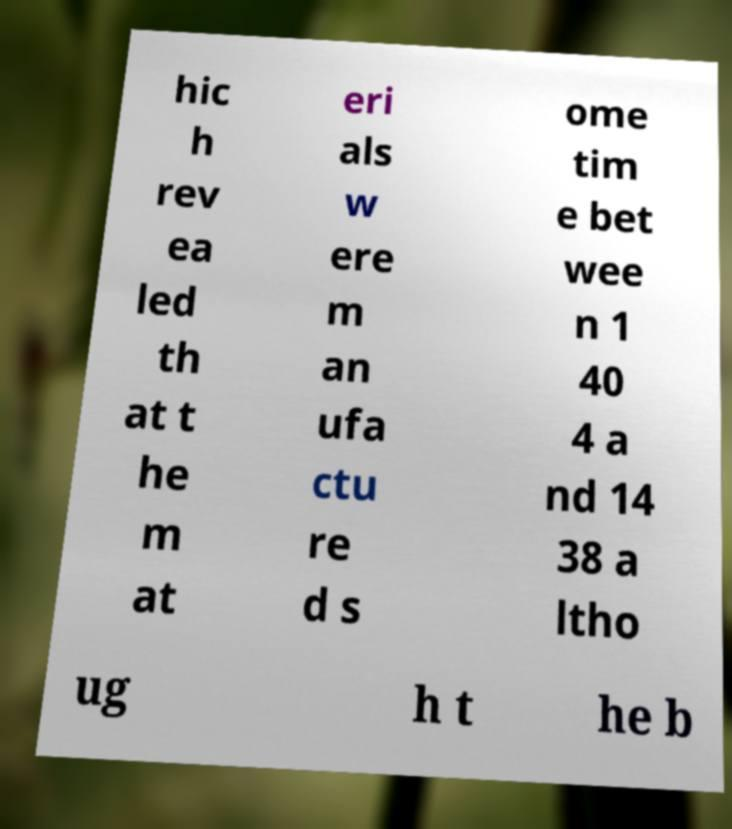Could you assist in decoding the text presented in this image and type it out clearly? hic h rev ea led th at t he m at eri als w ere m an ufa ctu re d s ome tim e bet wee n 1 40 4 a nd 14 38 a ltho ug h t he b 